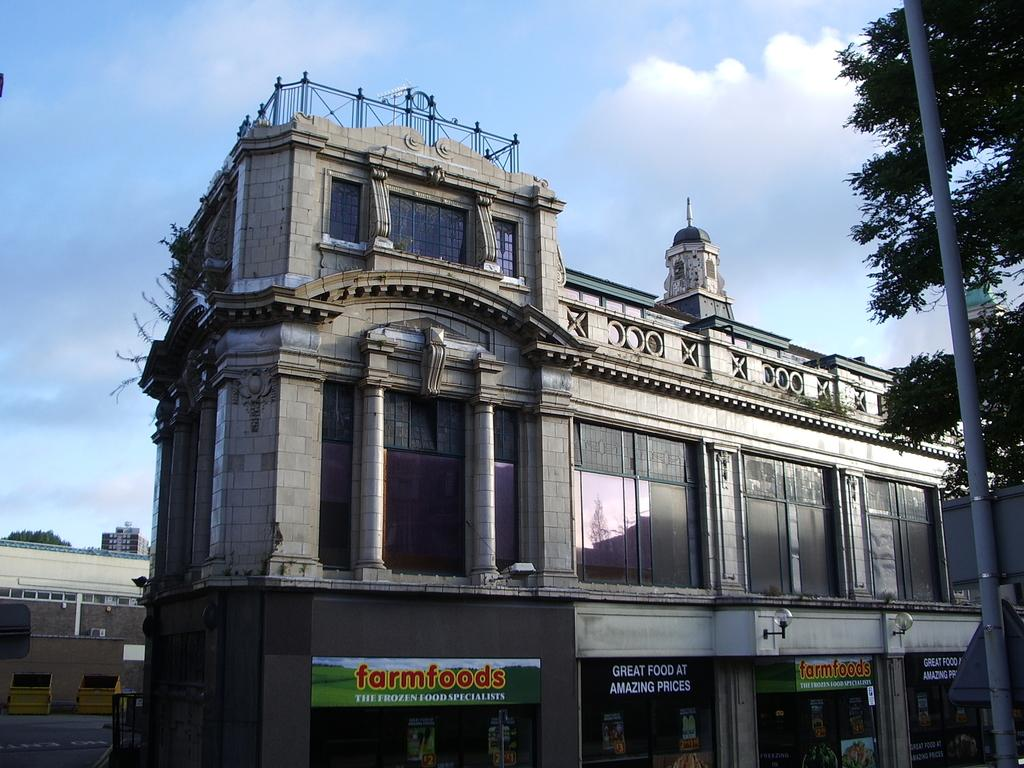<image>
Create a compact narrative representing the image presented. Farmfoods has a black banner that says great food at amazing prices. 